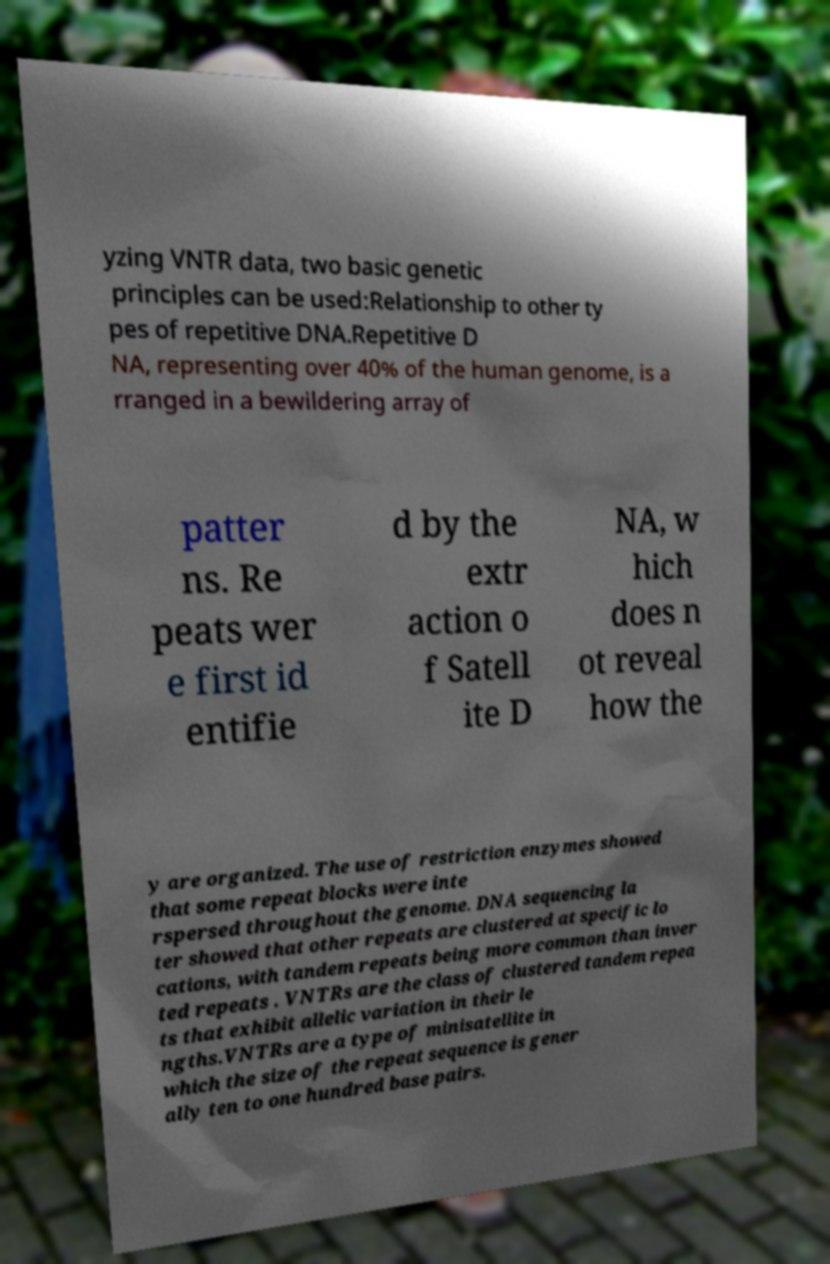Can you accurately transcribe the text from the provided image for me? yzing VNTR data, two basic genetic principles can be used:Relationship to other ty pes of repetitive DNA.Repetitive D NA, representing over 40% of the human genome, is a rranged in a bewildering array of patter ns. Re peats wer e first id entifie d by the extr action o f Satell ite D NA, w hich does n ot reveal how the y are organized. The use of restriction enzymes showed that some repeat blocks were inte rspersed throughout the genome. DNA sequencing la ter showed that other repeats are clustered at specific lo cations, with tandem repeats being more common than inver ted repeats . VNTRs are the class of clustered tandem repea ts that exhibit allelic variation in their le ngths.VNTRs are a type of minisatellite in which the size of the repeat sequence is gener ally ten to one hundred base pairs. 